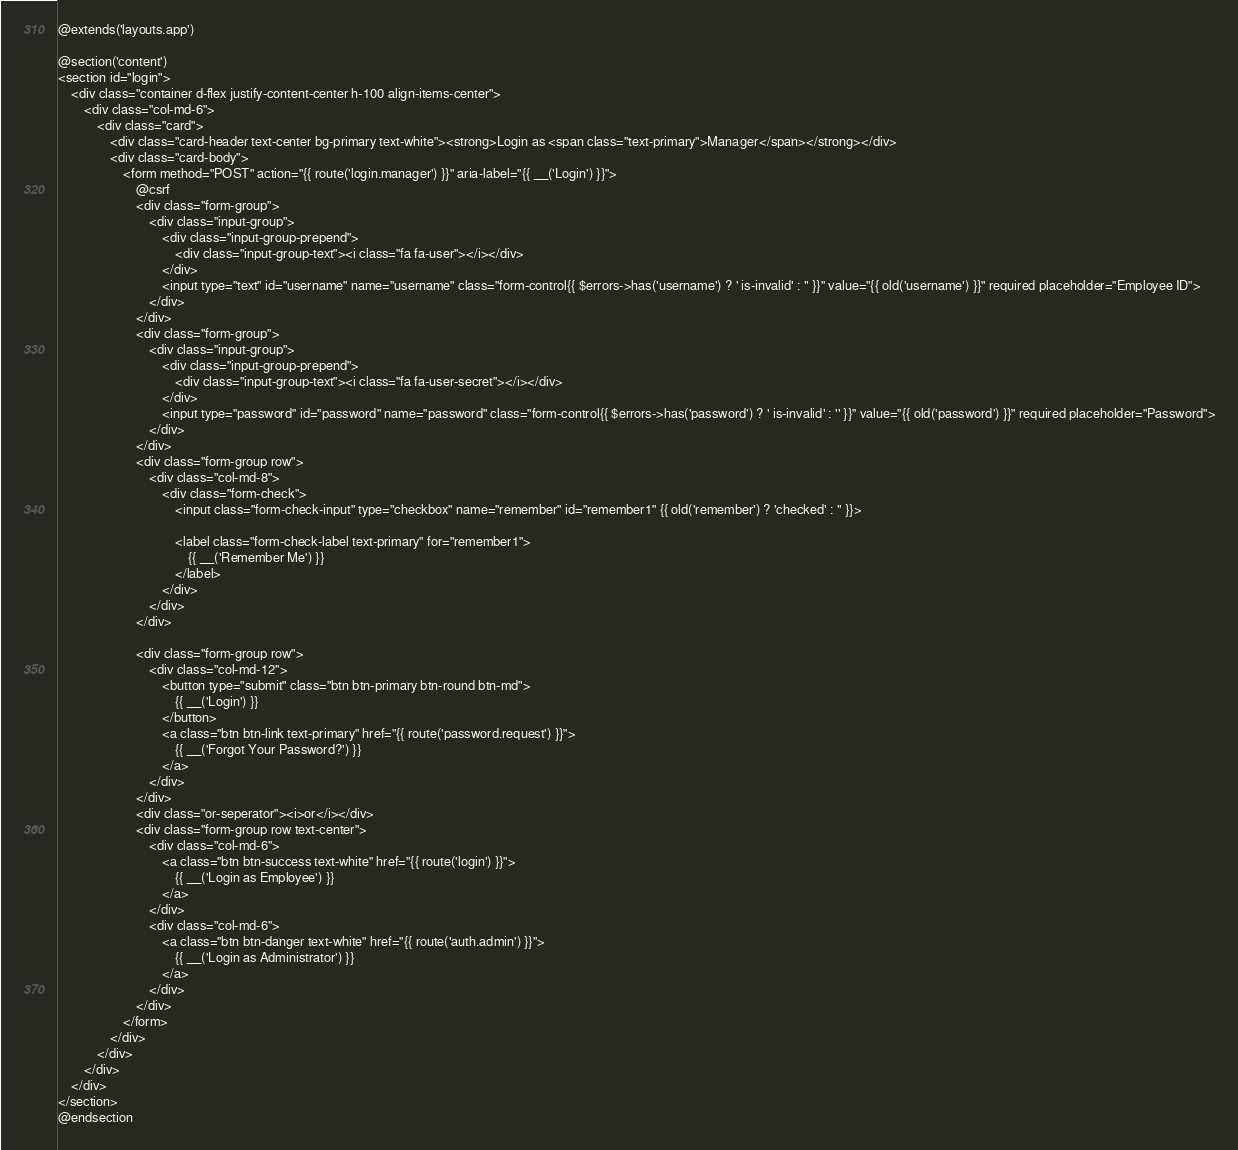<code> <loc_0><loc_0><loc_500><loc_500><_PHP_>@extends('layouts.app')

@section('content')
<section id="login">
    <div class="container d-flex justify-content-center h-100 align-items-center">
        <div class="col-md-6">
            <div class="card">
                <div class="card-header text-center bg-primary text-white"><strong>Login as <span class="text-primary">Manager</span></strong></div>
                <div class="card-body">
                    <form method="POST" action="{{ route('login.manager') }}" aria-label="{{ __('Login') }}">
                        @csrf
                        <div class="form-group">
                            <div class="input-group">
                                <div class="input-group-prepend">
                                    <div class="input-group-text"><i class="fa fa-user"></i></div>
                                </div>
                                <input type="text" id="username" name="username" class="form-control{{ $errors->has('username') ? ' is-invalid' : '' }}" value="{{ old('username') }}" required placeholder="Employee ID">
                            </div>
                        </div>
                        <div class="form-group">
                            <div class="input-group">
                                <div class="input-group-prepend">
                                    <div class="input-group-text"><i class="fa fa-user-secret"></i></div>
                                </div>
                                <input type="password" id="password" name="password" class="form-control{{ $errors->has('password') ? ' is-invalid' : '' }}" value="{{ old('password') }}" required placeholder="Password">
                            </div>
                        </div>
                        <div class="form-group row">
                            <div class="col-md-8">
                                <div class="form-check">
                                    <input class="form-check-input" type="checkbox" name="remember" id="remember1" {{ old('remember') ? 'checked' : '' }}>

                                    <label class="form-check-label text-primary" for="remember1">
                                        {{ __('Remember Me') }}
                                    </label>
                                </div>
                            </div>
                        </div>

                        <div class="form-group row">
                            <div class="col-md-12">
                                <button type="submit" class="btn btn-primary btn-round btn-md">
                                    {{ __('Login') }}
                                </button>
                                <a class="btn btn-link text-primary" href="{{ route('password.request') }}">
                                    {{ __('Forgot Your Password?') }}
                                </a>
                            </div>
                        </div>
                        <div class="or-seperator"><i>or</i></div>
                        <div class="form-group row text-center">
                            <div class="col-md-6">
                                <a class="btn btn-success text-white" href="{{ route('login') }}">
                                    {{ __('Login as Employee') }}
                                </a>
                            </div>
                            <div class="col-md-6">
                                <a class="btn btn-danger text-white" href="{{ route('auth.admin') }}">
                                    {{ __('Login as Administrator') }}
                                </a>
                            </div>
                        </div>
                    </form>
                </div>
            </div>
        </div>
    </div>
</section>
@endsection</code> 